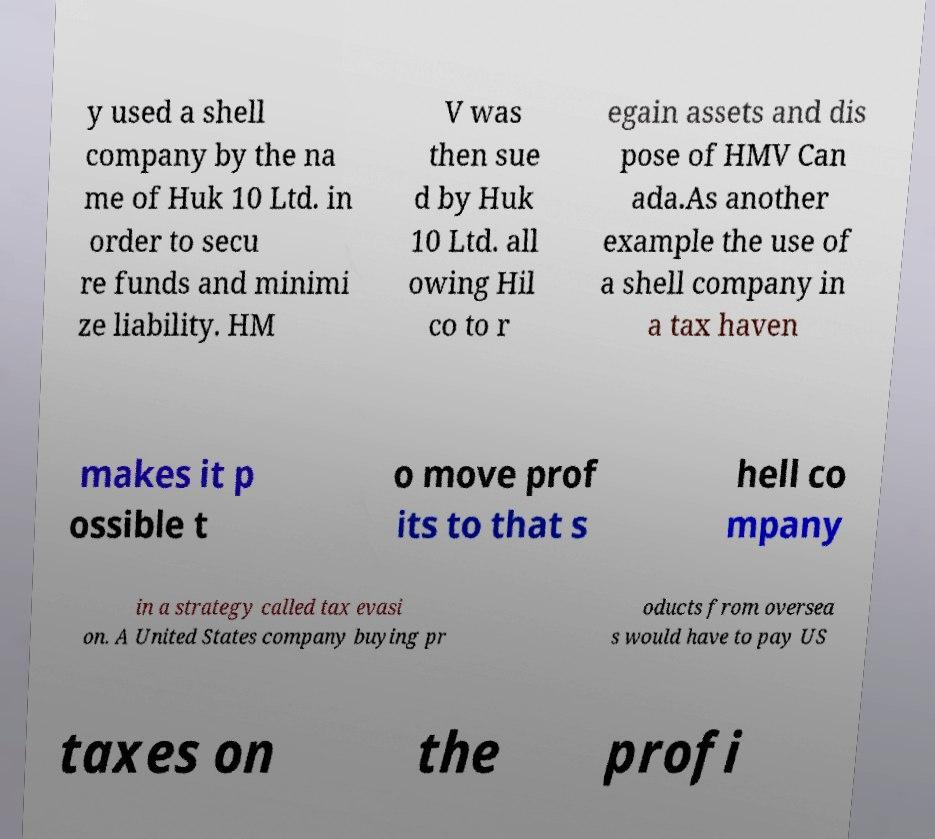I need the written content from this picture converted into text. Can you do that? y used a shell company by the na me of Huk 10 Ltd. in order to secu re funds and minimi ze liability. HM V was then sue d by Huk 10 Ltd. all owing Hil co to r egain assets and dis pose of HMV Can ada.As another example the use of a shell company in a tax haven makes it p ossible t o move prof its to that s hell co mpany in a strategy called tax evasi on. A United States company buying pr oducts from oversea s would have to pay US taxes on the profi 